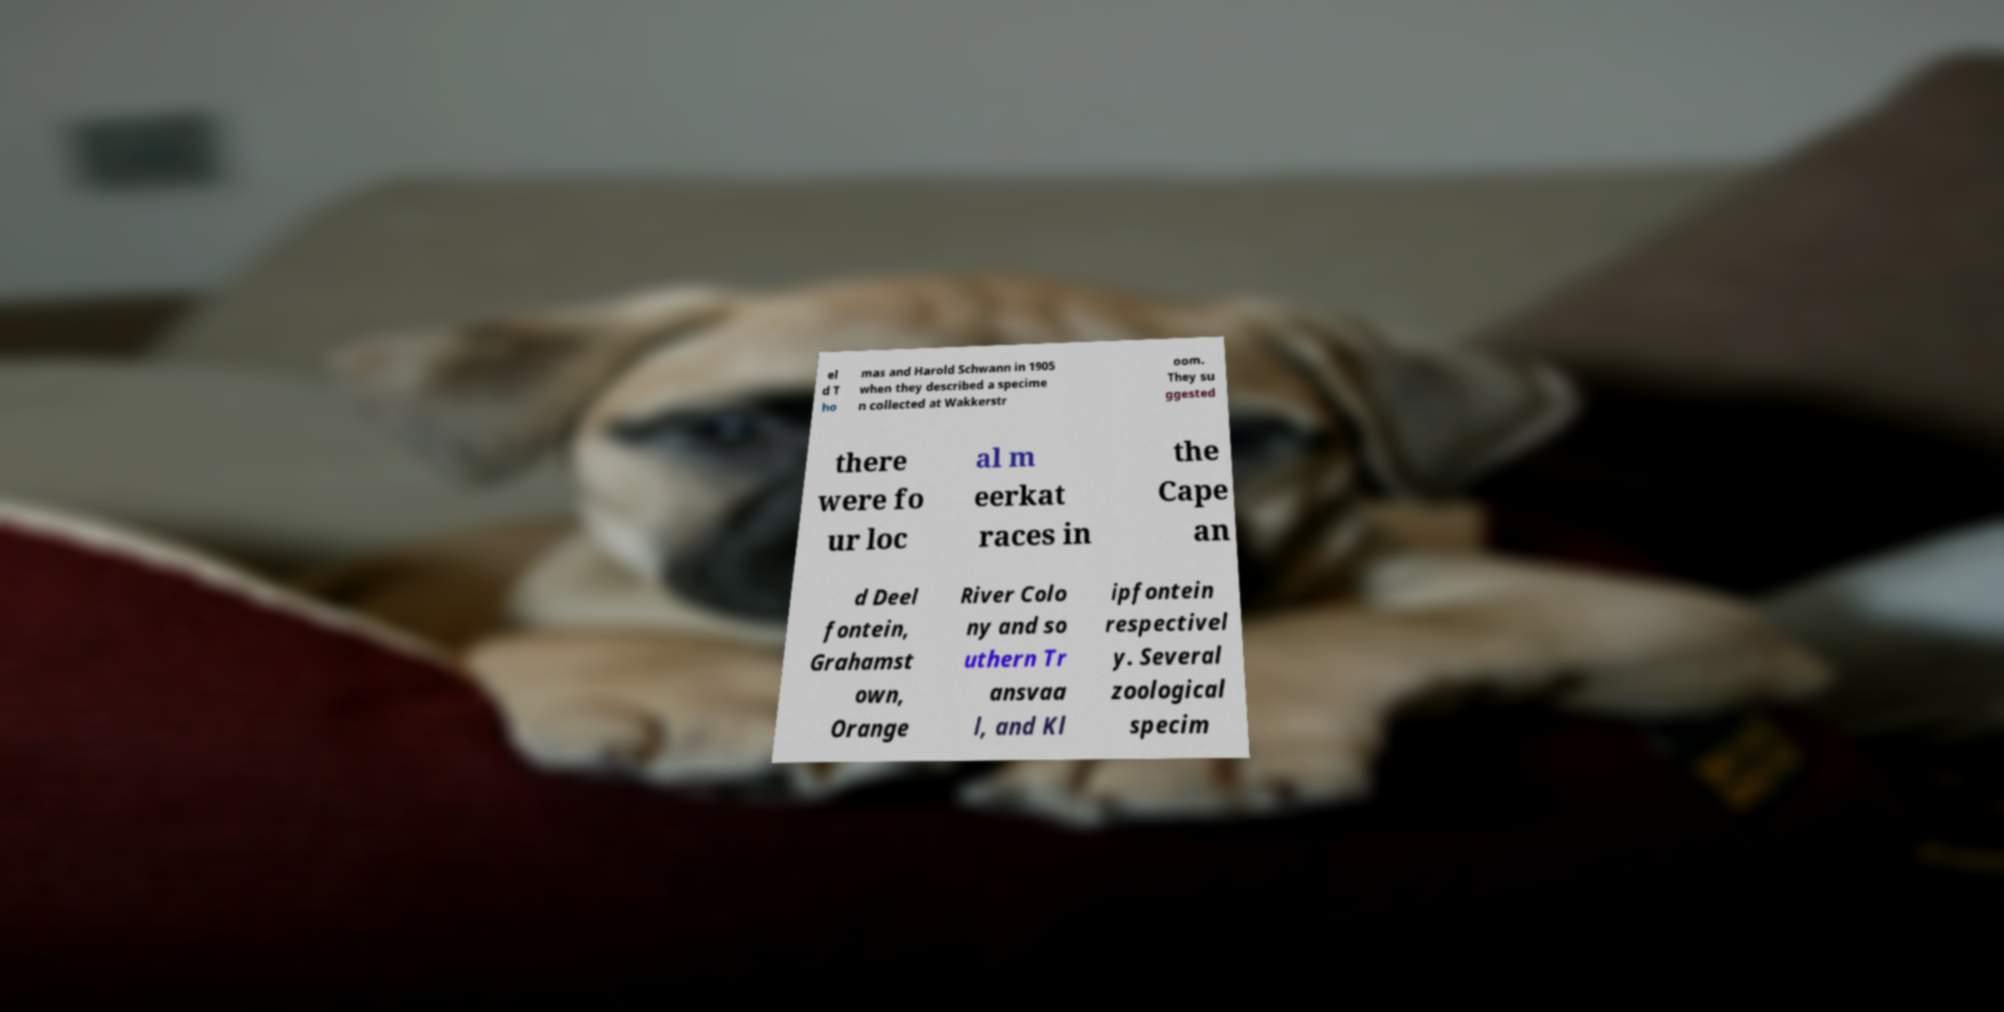Please read and relay the text visible in this image. What does it say? el d T ho mas and Harold Schwann in 1905 when they described a specime n collected at Wakkerstr oom. They su ggested there were fo ur loc al m eerkat races in the Cape an d Deel fontein, Grahamst own, Orange River Colo ny and so uthern Tr ansvaa l, and Kl ipfontein respectivel y. Several zoological specim 